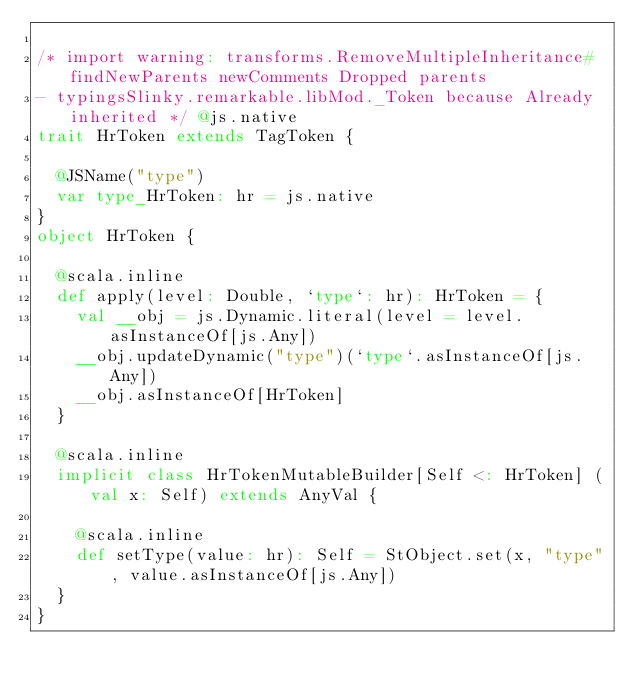Convert code to text. <code><loc_0><loc_0><loc_500><loc_500><_Scala_>
/* import warning: transforms.RemoveMultipleInheritance#findNewParents newComments Dropped parents 
- typingsSlinky.remarkable.libMod._Token because Already inherited */ @js.native
trait HrToken extends TagToken {
  
  @JSName("type")
  var type_HrToken: hr = js.native
}
object HrToken {
  
  @scala.inline
  def apply(level: Double, `type`: hr): HrToken = {
    val __obj = js.Dynamic.literal(level = level.asInstanceOf[js.Any])
    __obj.updateDynamic("type")(`type`.asInstanceOf[js.Any])
    __obj.asInstanceOf[HrToken]
  }
  
  @scala.inline
  implicit class HrTokenMutableBuilder[Self <: HrToken] (val x: Self) extends AnyVal {
    
    @scala.inline
    def setType(value: hr): Self = StObject.set(x, "type", value.asInstanceOf[js.Any])
  }
}
</code> 